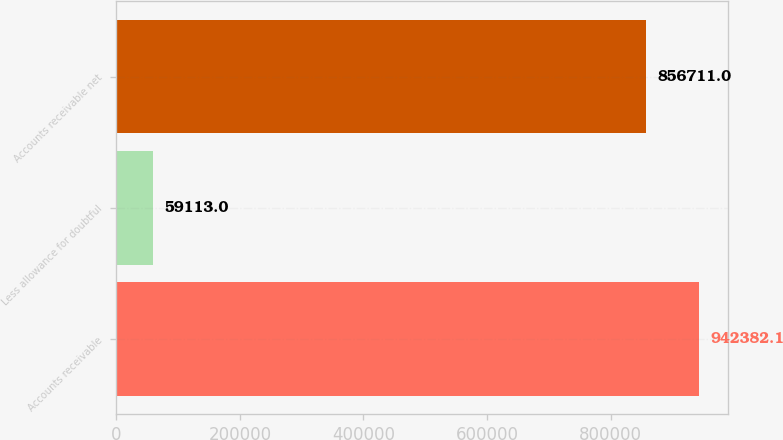Convert chart to OTSL. <chart><loc_0><loc_0><loc_500><loc_500><bar_chart><fcel>Accounts receivable<fcel>Less allowance for doubtful<fcel>Accounts receivable net<nl><fcel>942382<fcel>59113<fcel>856711<nl></chart> 